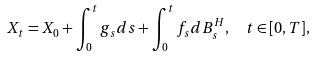Convert formula to latex. <formula><loc_0><loc_0><loc_500><loc_500>X _ { t } = X _ { 0 } + \int _ { 0 } ^ { t } g _ { s } d s + \int _ { 0 } ^ { t } f _ { s } d B _ { s } ^ { H } , \ \ t \in [ 0 , T ] ,</formula> 